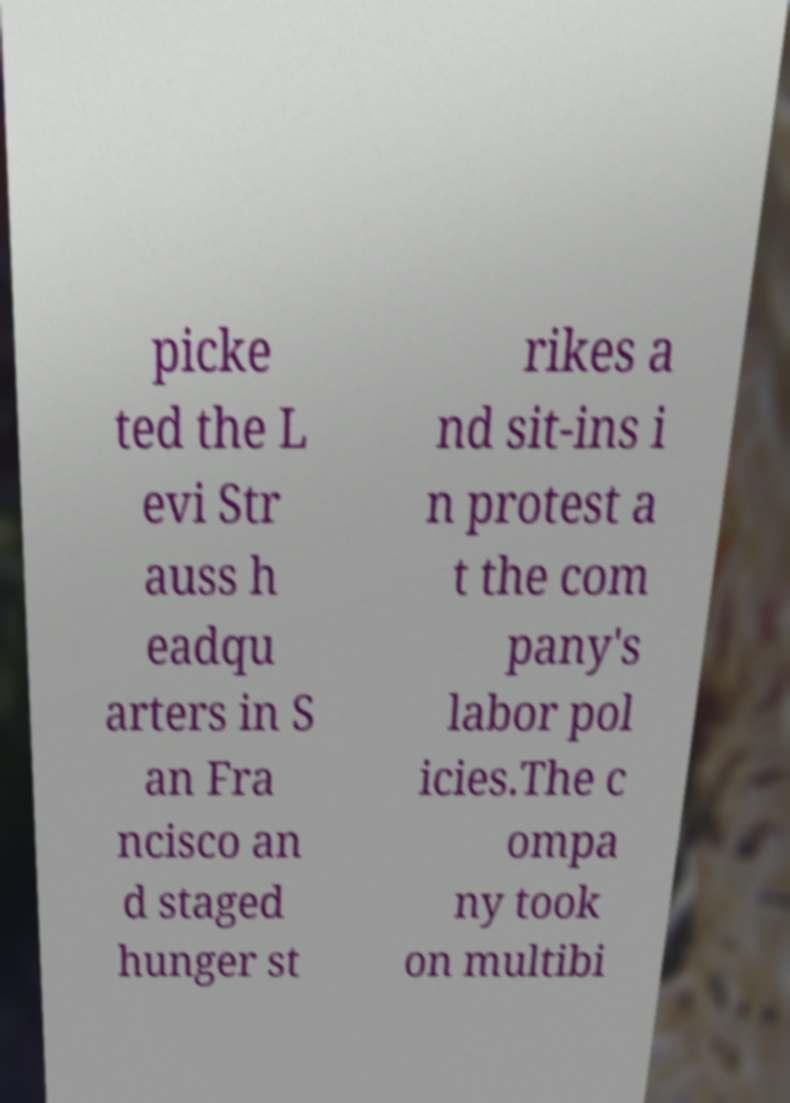Please identify and transcribe the text found in this image. picke ted the L evi Str auss h eadqu arters in S an Fra ncisco an d staged hunger st rikes a nd sit-ins i n protest a t the com pany's labor pol icies.The c ompa ny took on multibi 